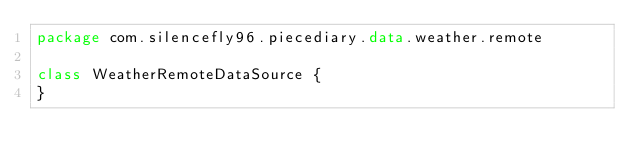<code> <loc_0><loc_0><loc_500><loc_500><_Kotlin_>package com.silencefly96.piecediary.data.weather.remote

class WeatherRemoteDataSource {
}</code> 